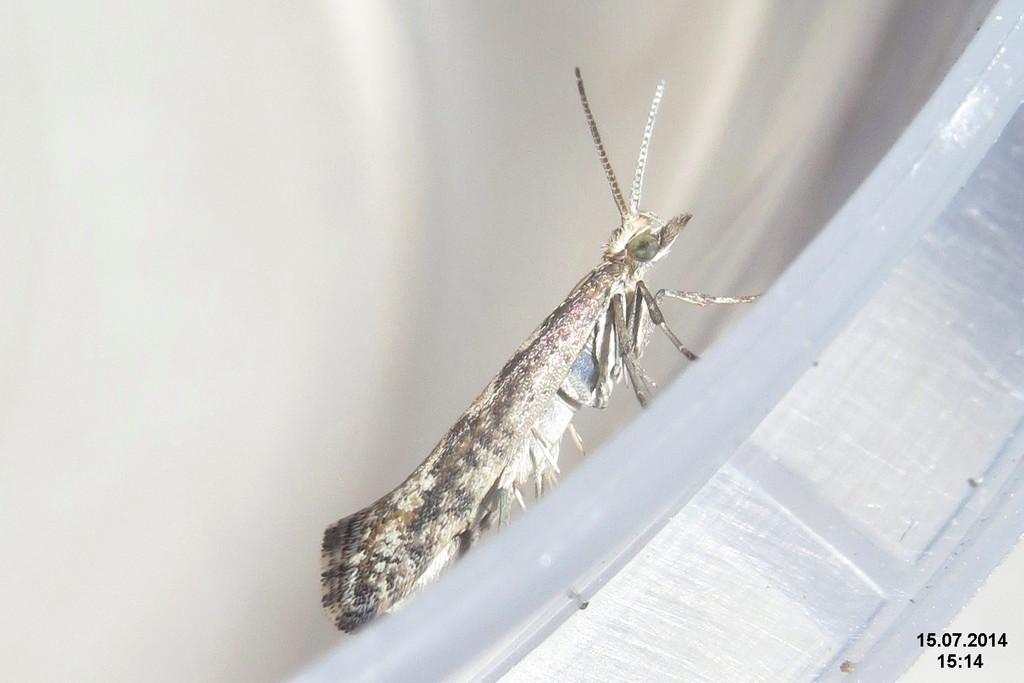What type of creature is present in the image? There is an insect in the image. Can you describe the background of the image? The background of the image is blurry. Where are the numbers located in the image? The numbers are at the bottom right corner of the image. What type of riddle can be solved by the clam in the image? There is no clam present in the image, so it is not possible to solve a riddle involving a clam. 